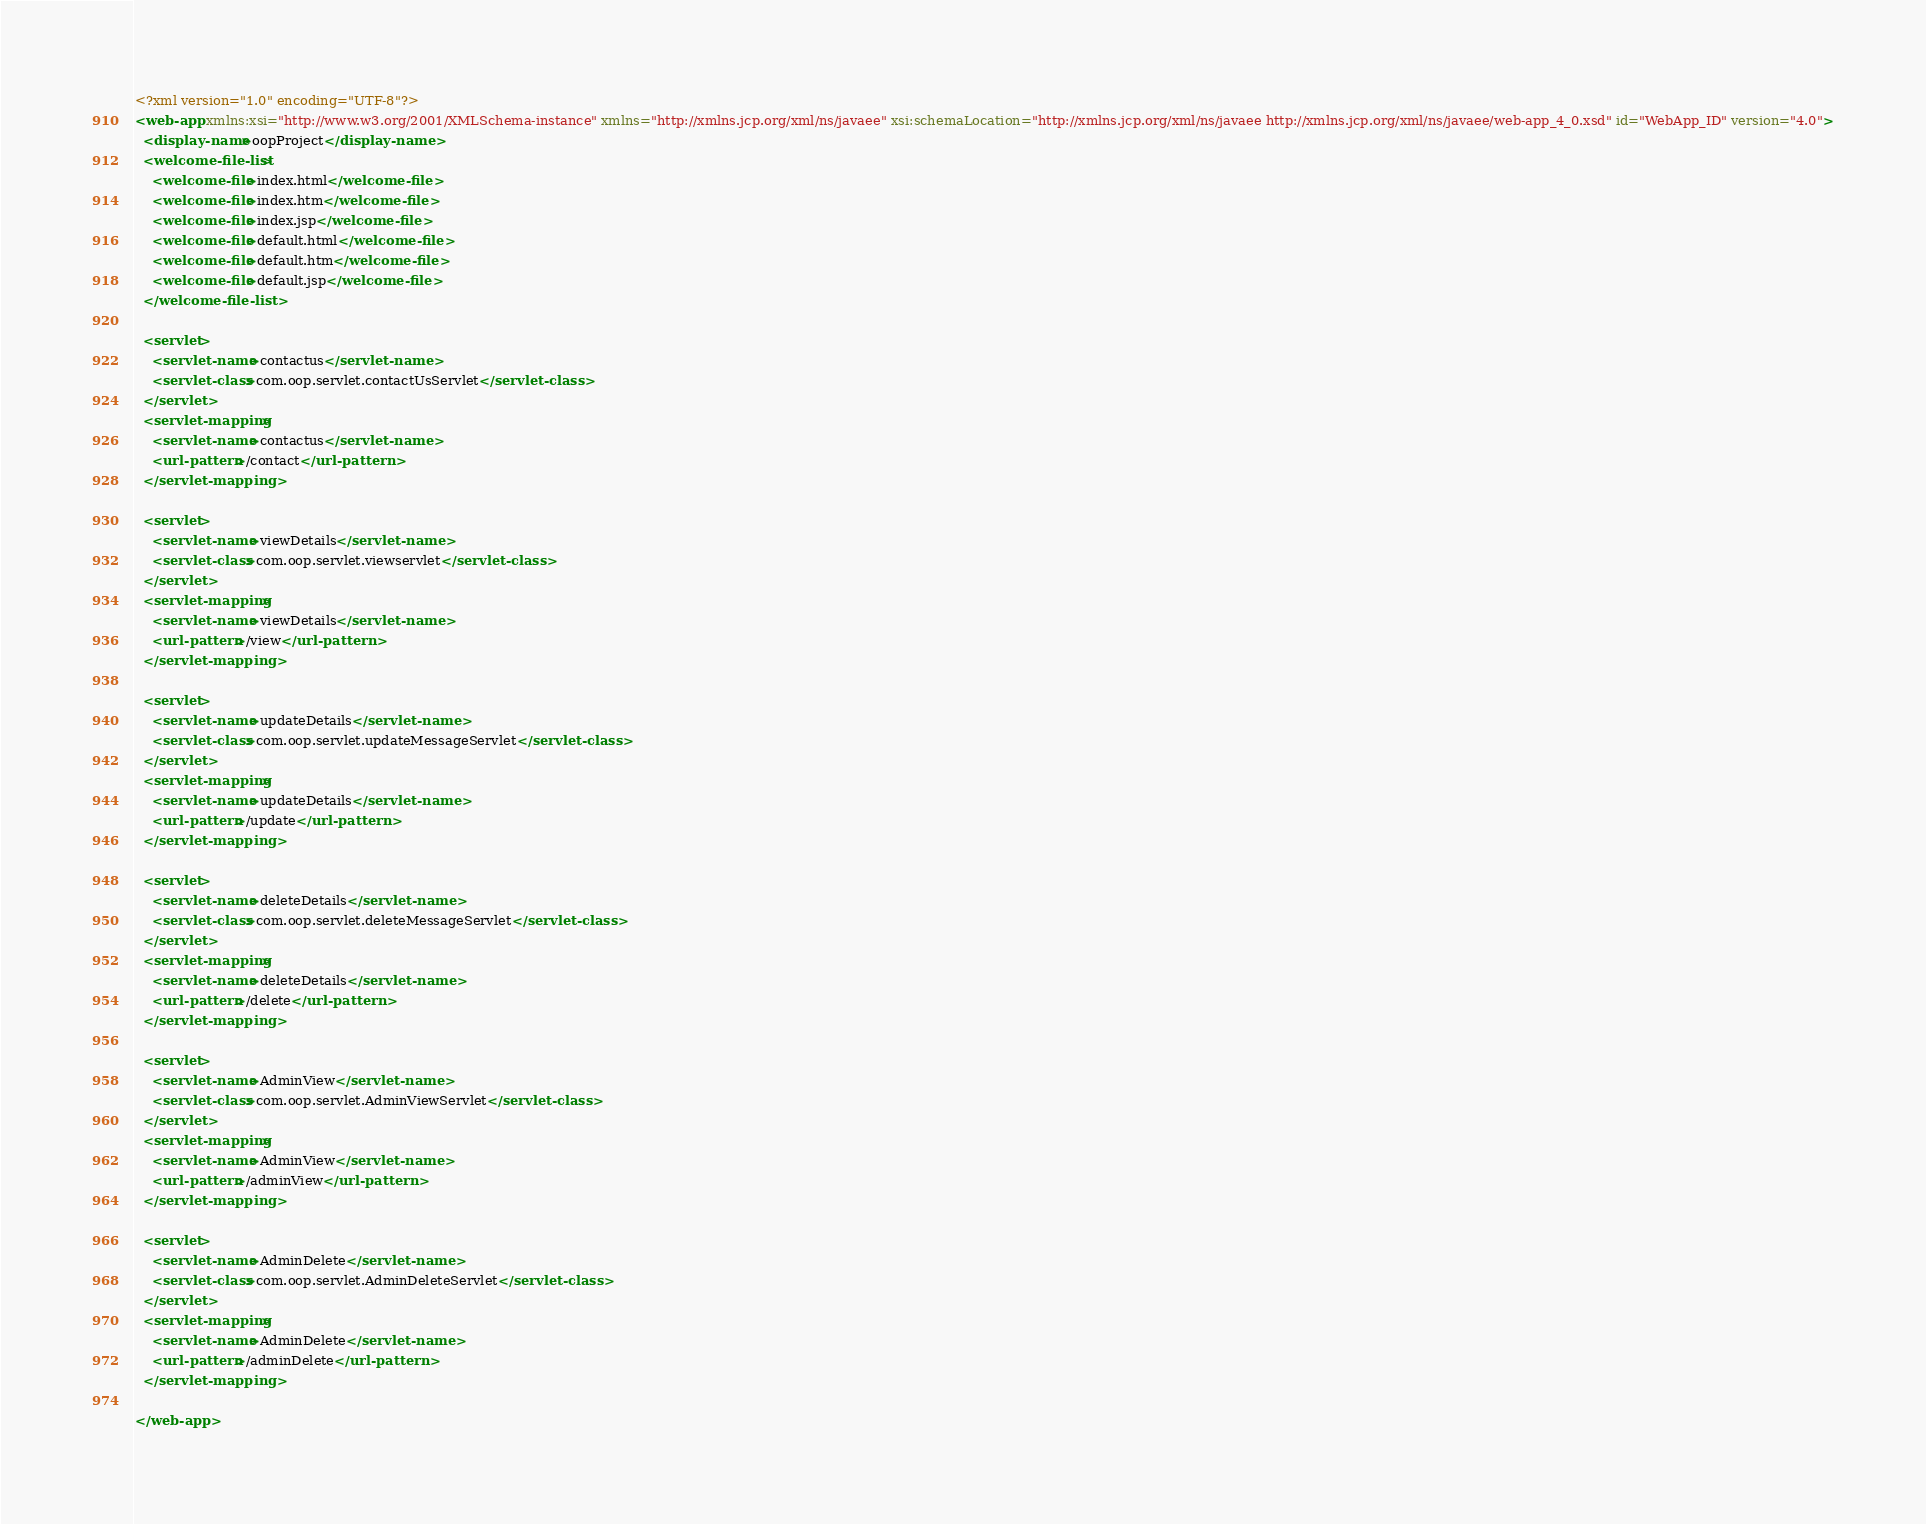Convert code to text. <code><loc_0><loc_0><loc_500><loc_500><_XML_><?xml version="1.0" encoding="UTF-8"?>
<web-app xmlns:xsi="http://www.w3.org/2001/XMLSchema-instance" xmlns="http://xmlns.jcp.org/xml/ns/javaee" xsi:schemaLocation="http://xmlns.jcp.org/xml/ns/javaee http://xmlns.jcp.org/xml/ns/javaee/web-app_4_0.xsd" id="WebApp_ID" version="4.0">
  <display-name>oopProject</display-name>
  <welcome-file-list>
    <welcome-file>index.html</welcome-file>
    <welcome-file>index.htm</welcome-file>
    <welcome-file>index.jsp</welcome-file>
    <welcome-file>default.html</welcome-file>
    <welcome-file>default.htm</welcome-file>
    <welcome-file>default.jsp</welcome-file>
  </welcome-file-list>
  
  <servlet>
  	<servlet-name>contactus</servlet-name>
  	<servlet-class>com.oop.servlet.contactUsServlet</servlet-class>
  </servlet>
  <servlet-mapping>
  	<servlet-name>contactus</servlet-name>
  	<url-pattern>/contact</url-pattern>
  </servlet-mapping>
  
  <servlet>
  	<servlet-name>viewDetails</servlet-name>
  	<servlet-class>com.oop.servlet.viewservlet</servlet-class>
  </servlet>
  <servlet-mapping>
  	<servlet-name>viewDetails</servlet-name>
  	<url-pattern>/view</url-pattern>
  </servlet-mapping>
  
  <servlet>
  	<servlet-name>updateDetails</servlet-name>
  	<servlet-class>com.oop.servlet.updateMessageServlet</servlet-class>
  </servlet>
  <servlet-mapping>
  	<servlet-name>updateDetails</servlet-name>
  	<url-pattern>/update</url-pattern>
  </servlet-mapping>
  
  <servlet>
  	<servlet-name>deleteDetails</servlet-name>
  	<servlet-class>com.oop.servlet.deleteMessageServlet</servlet-class>
  </servlet>
  <servlet-mapping>
  	<servlet-name>deleteDetails</servlet-name>
  	<url-pattern>/delete</url-pattern>
  </servlet-mapping>
  
  <servlet>
  	<servlet-name>AdminView</servlet-name>
  	<servlet-class>com.oop.servlet.AdminViewServlet</servlet-class>
  </servlet>
  <servlet-mapping>
  	<servlet-name>AdminView</servlet-name>
  	<url-pattern>/adminView</url-pattern>
  </servlet-mapping>
  
  <servlet>
  	<servlet-name>AdminDelete</servlet-name>
  	<servlet-class>com.oop.servlet.AdminDeleteServlet</servlet-class>
  </servlet>
  <servlet-mapping>
  	<servlet-name>AdminDelete</servlet-name>
  	<url-pattern>/adminDelete</url-pattern>
  </servlet-mapping>
  
</web-app></code> 